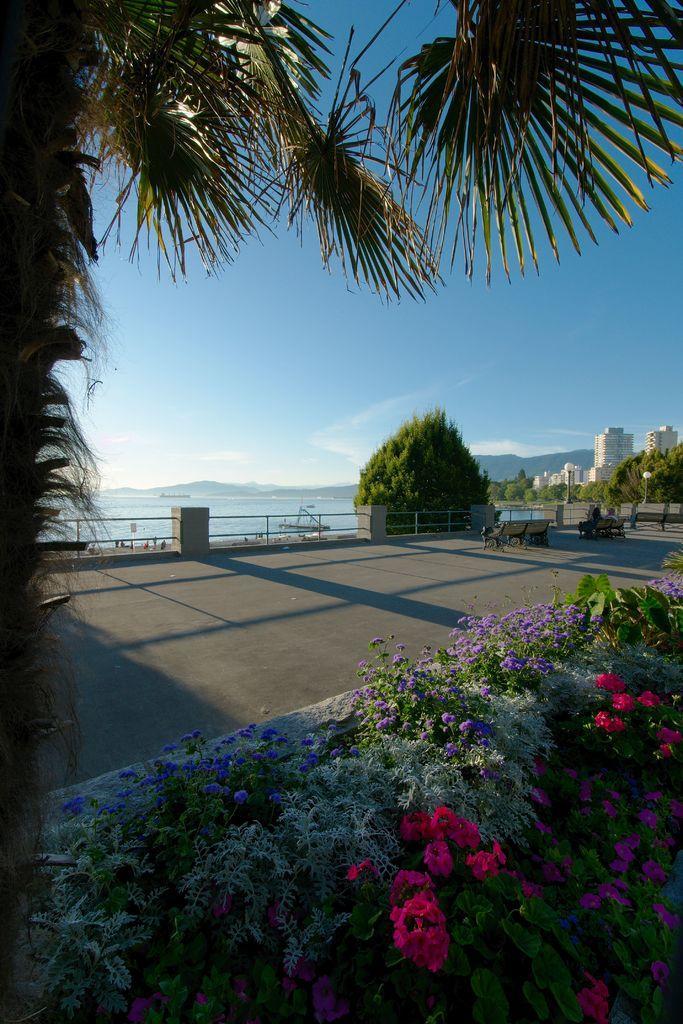Could you give a brief overview of what you see in this image? Here we can see plants with flowers. Far there are buildings, trees, water and people. Sky is in blue color. 